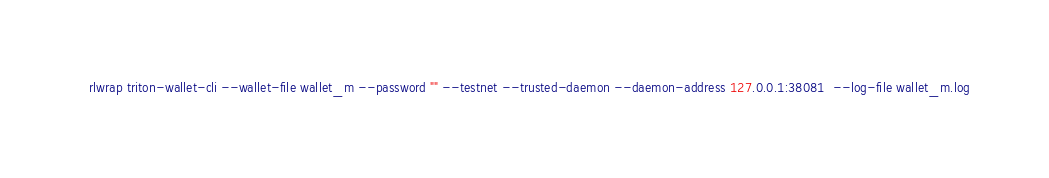<code> <loc_0><loc_0><loc_500><loc_500><_Bash_>
rlwrap triton-wallet-cli --wallet-file wallet_m --password "" --testnet --trusted-daemon --daemon-address 127.0.0.1:38081  --log-file wallet_m.log

</code> 